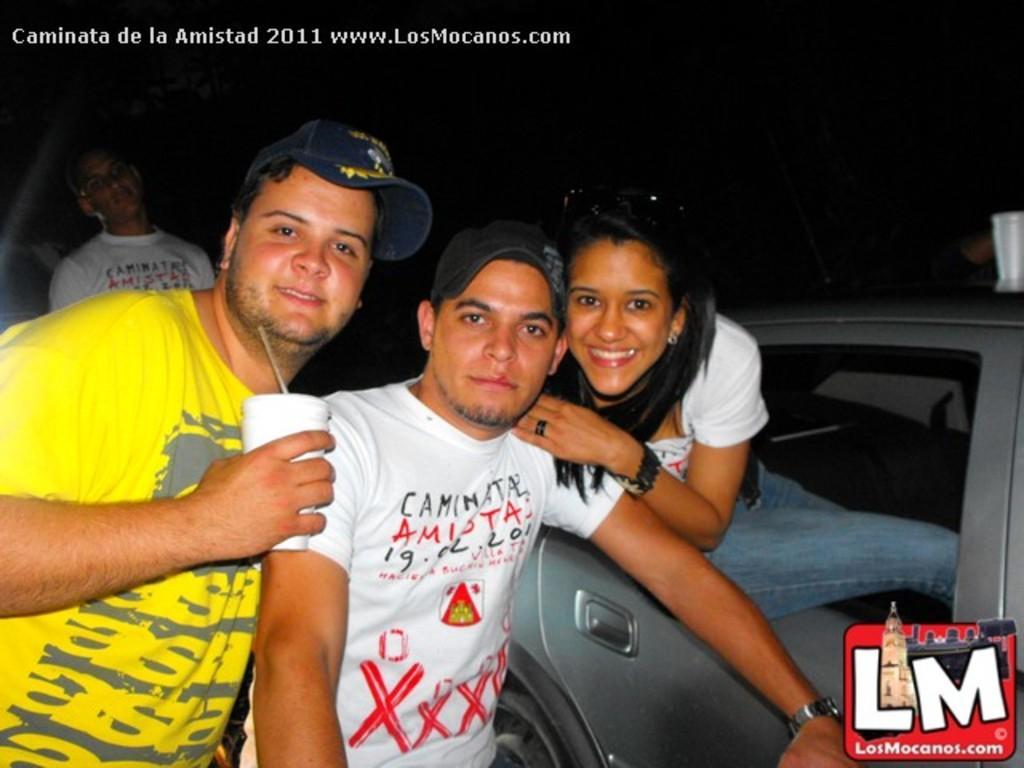Describe this image in one or two sentences. In this image i can see two men standing and a woman sitting in car at the back ground i can see a man. 